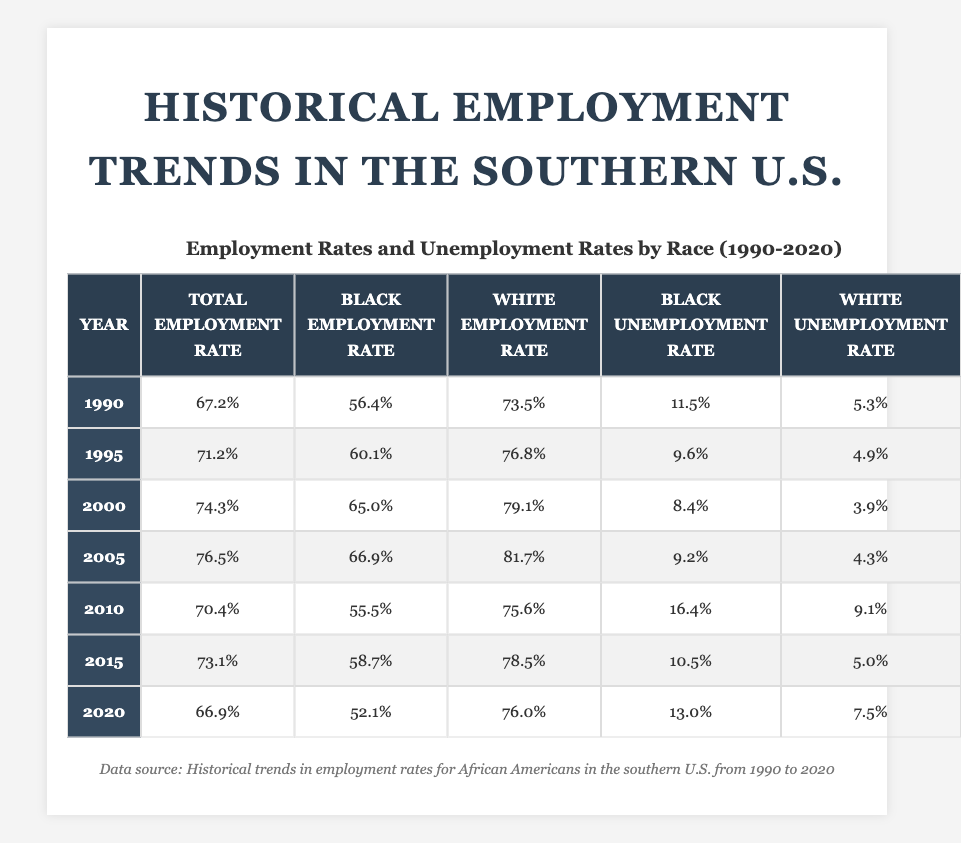What was the black employment rate in 1990? Looking at the table under the year 1990, the black employment rate is explicitly listed as 56.4%.
Answer: 56.4% What was the white unemployment rate in 2015? Checking the year 2015, the white unemployment rate is found in the corresponding column, which is 5.0%.
Answer: 5.0% In which year did the black employment rate reach its highest point? The highest black employment rate can be determined by scanning through the black employment rates listed for each year. The peak is in 2000 at 65.0%.
Answer: 2000 What is the difference between the black and white employment rates in 2010? In 2010, the black employment rate is 55.5% and the white employment rate is 75.6%. To find the difference, subtract the black rate from the white rate: 75.6% - 55.5% = 20.1%.
Answer: 20.1% What was the trend in total employment rate from 1990 to 2020? By observing the total employment rates from each year, the values are: 67.2%, 71.2%, 74.3%, 76.5%, 70.4%, 73.1%, and 66.9%. Taking into account these values, the trend shows an overall increase up to 2005, followed by a drop in 2010, a slight rise in 2015, and then another decrease in 2020.
Answer: Increase then decrease What was the average unemployment rate for black individuals from 1990 to 2020? The unemployment rates for black individuals over the years are: 11.5%, 9.6%, 8.4%, 9.2%, 16.4%, 10.5%, and 13.0%. Summing these gives 78.6%, and dividing by 7 (the number of years) results in approximately 11.2%.
Answer: 11.2% Did the black employment rate ever exceed 60% between 1990 and 2020? Analyzing the black employment rates across the years, the rates are 56.4%, 60.1%, 65.0%, 66.9%, 55.5%, 58.7%, and 52.1%. Since the rates exceeded 60% in 1995 and 2000, the answer is yes.
Answer: Yes Which demographic experienced the highest unemployment rates in 2010? In 2010, the unemployment rates were 16.4% for blacks and 9.1% for whites. Comparing these rates shows that the unemployment rate for black individuals is higher than that for white individuals.
Answer: Blacks What was the percentage decrease in black employment rate from 2005 to 2020? The black employment rate in 2005 was 66.9% and in 2020 it was 52.1%. The decrease is calculated as 66.9% - 52.1% = 14.8%.
Answer: 14.8% 